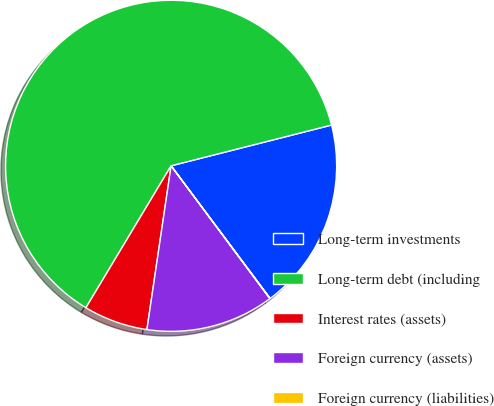Convert chart to OTSL. <chart><loc_0><loc_0><loc_500><loc_500><pie_chart><fcel>Long-term investments<fcel>Long-term debt (including<fcel>Interest rates (assets)<fcel>Foreign currency (assets)<fcel>Foreign currency (liabilities)<nl><fcel>18.75%<fcel>62.43%<fcel>6.27%<fcel>12.51%<fcel>0.03%<nl></chart> 